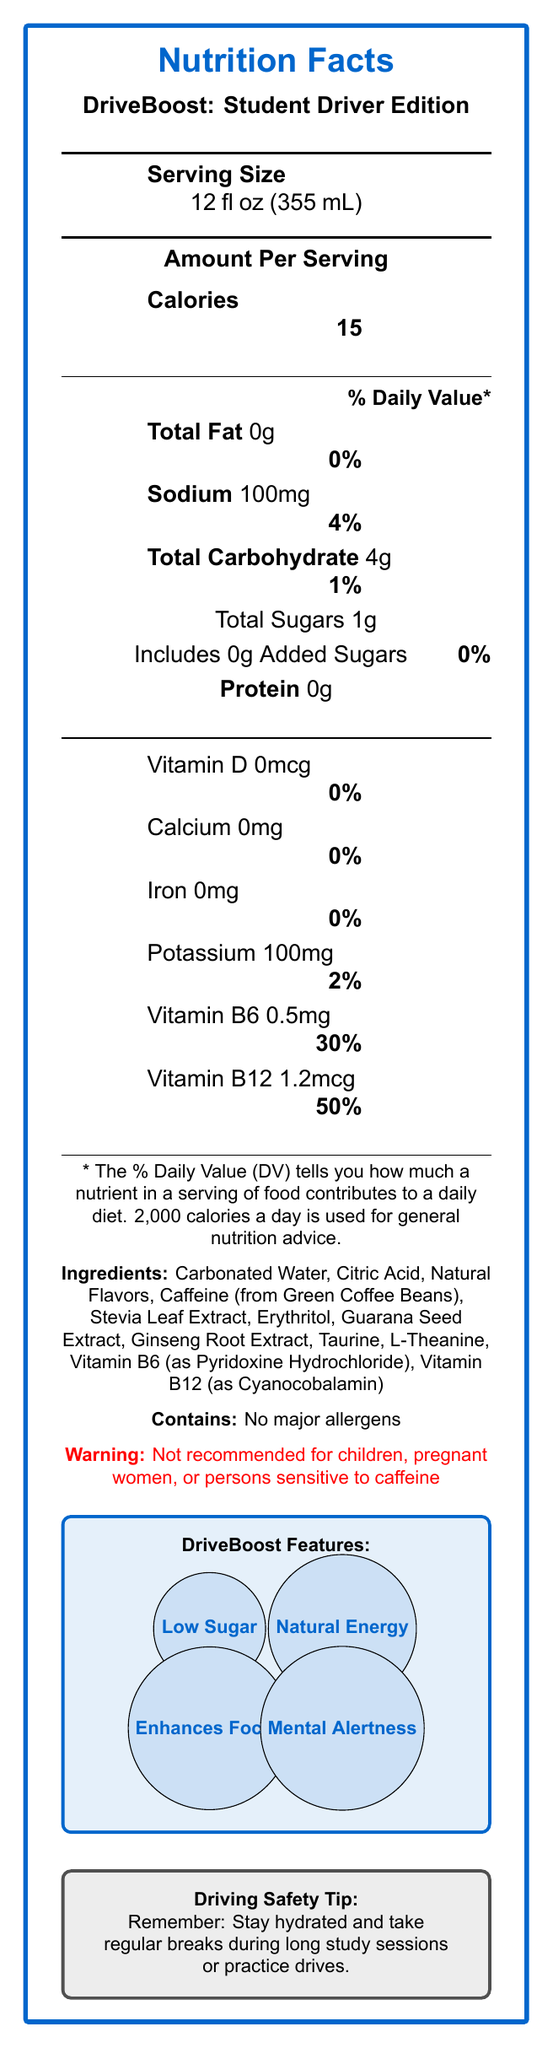what is the serving size? The serving size is listed at the top of the Nutrition Facts Label as 12 fl oz (355 mL).
Answer: 12 fl oz (355 mL) how many calories are in one serving of DriveBoost: Student Driver Edition? The calories per serving are listed as 15 under "Amount Per Serving".
Answer: 15 what is the total amount of sugars per serving? The "Total Sugars" amount is 1g as listed under "Total Carbohydrate".
Answer: 1g how much caffeine is in DriveBoost: Student Driver Edition? The caffeine content of 80mg is listed separately from the nutritional data but within the document content.
Answer: 80mg what are the main ingredients of DriveBoost: Student Driver Edition? The ingredients are listed in a section labeled "Ingredients", detailing the components used in the energy drink.
Answer: Carbonated Water, Citric Acid, Natural Flavors, Caffeine (from Green Coffee Beans), Stevia Leaf Extract, Erythritol, Guarana Seed Extract, Ginseng Root Extract, Taurine, L-Theanine, Vitamin B6 (as Pyridoxine Hydrochloride), Vitamin B12 (as Cyanocobalamin) what is the daily value percentage of Vitamin B12 per serving? The daily value percentage for Vitamin B12 is given as 50% in the nutritional data section.
Answer: 50% how much sodium does one serving contain? The "Sodium" content per serving is listed as 100mg under the nutritional information.
Answer: 100mg how much protein is in one serving of DriveBoost: Student Driver Edition? The protein content is given as 0g under the nutritional facts.
Answer: 0g which nutrient has the highest daily value percentage in DriveBoost: Student Driver Edition? A. Vitamin D B. Vitamin B6 C. Sodium Vitamin B6 has the highest daily value percentage at 30%, as listed in the nutritional facts.
Answer: B. Vitamin B6 what does the label say about its suitability for children or pregnant women? A. It's safe for all ages B. Not recommended for children C. Only recommended for adults The warning section clearly states that the product is not recommended for children, pregnant women, or persons sensitive to caffeine.
Answer: B. Not recommended for children is there any added sugar in this energy drink? According to the Nutrition Facts, it includes 0g of added sugars.
Answer: No does DriveBoost: Student Driver Edition contain any major allergens? The allergen statement specifies that it contains no major allergens.
Answer: No does DriveBoost: Student Driver Edition support mental alertness? One of the marketing claims listed is "Supports Mental Alertness".
Answer: Yes summarize the main nutritional and safety information about DriveBoost: Student Driver Edition. The document lists the nutritional information, including calories, vitamins, caffeine content, and ingredients, along with marketing claims and safety warnings.
Answer: DriveBoost: Student Driver Edition is a low-calorie, low-sugar energy drink with significant amounts of Vitamin B6 and Vitamin B12. It contains caffeine and other natural extracts to enhance focus and mental alertness and is not recommended for children, pregnant women, or those sensitive to caffeine. It has no major allergens. how many different forms of Vitamin B are present in DriveBoost: Student Driver Edition? The document lists Vitamin B6 and Vitamin B12 as part of the nutritional information.
Answer: Two what is the reason behind setting a daily value percentage? The document does not provide information on why daily value percentages are set.
Answer: Cannot be determined is DriveBoost: Student Driver Edition considered a high-sodium beverage? With only 100mg of sodium per serving, resulting in 4% of the daily value, it is not considered high-sodium.
Answer: No 